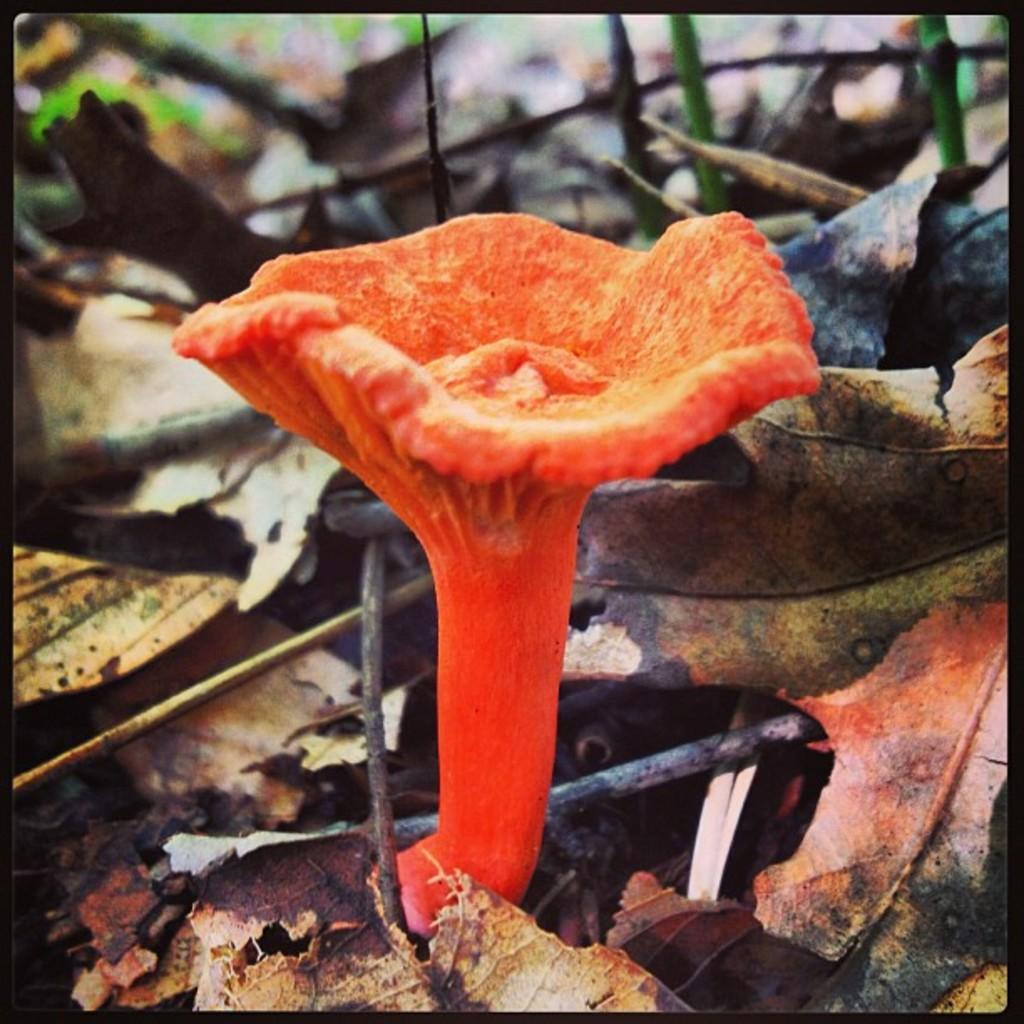What type of plant can be seen in the image? There is a flower in the image. What other natural elements are present in the image? Dry leaves and twigs are visible in the image. How are the borders of the image presented? The image has black color borders. What part of the brain can be seen in the image? There is no part of the brain present in the image; it features a flower, dry leaves, and twigs. How many feet are visible in the image? There are no feet visible in the image. 